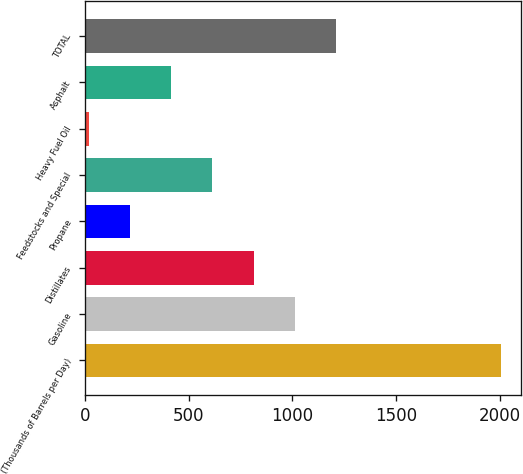<chart> <loc_0><loc_0><loc_500><loc_500><bar_chart><fcel>(Thousands of Barrels per Day)<fcel>Gasoline<fcel>Distillates<fcel>Propane<fcel>Feedstocks and Special<fcel>Heavy Fuel Oil<fcel>Asphalt<fcel>TOTAL<nl><fcel>2002<fcel>1011<fcel>812.8<fcel>218.2<fcel>614.6<fcel>20<fcel>416.4<fcel>1209.2<nl></chart> 